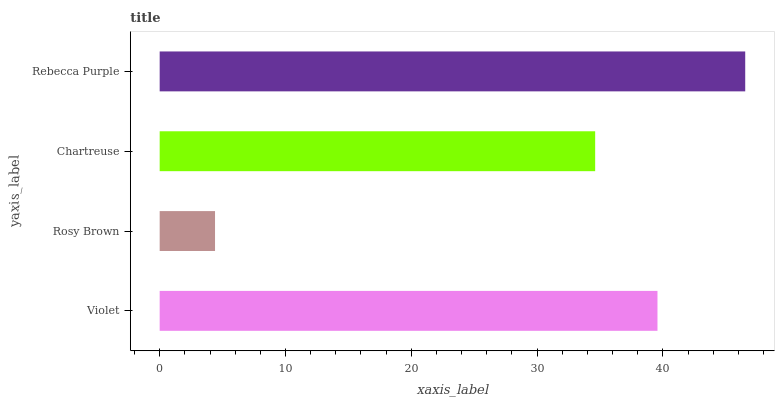Is Rosy Brown the minimum?
Answer yes or no. Yes. Is Rebecca Purple the maximum?
Answer yes or no. Yes. Is Chartreuse the minimum?
Answer yes or no. No. Is Chartreuse the maximum?
Answer yes or no. No. Is Chartreuse greater than Rosy Brown?
Answer yes or no. Yes. Is Rosy Brown less than Chartreuse?
Answer yes or no. Yes. Is Rosy Brown greater than Chartreuse?
Answer yes or no. No. Is Chartreuse less than Rosy Brown?
Answer yes or no. No. Is Violet the high median?
Answer yes or no. Yes. Is Chartreuse the low median?
Answer yes or no. Yes. Is Rosy Brown the high median?
Answer yes or no. No. Is Rebecca Purple the low median?
Answer yes or no. No. 